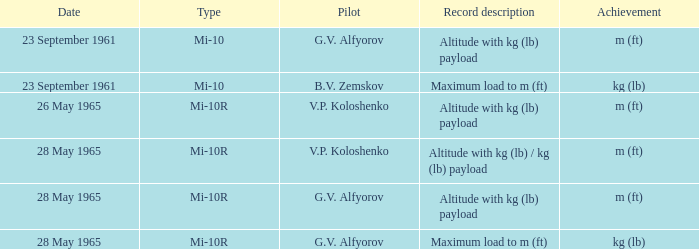Achievement of m (ft), and a Type of mi-10r, and a Pilot of v.p. koloshenko, and a Date of 28 may 1965 had what record description? Altitude with kg (lb) / kg (lb) payload. 